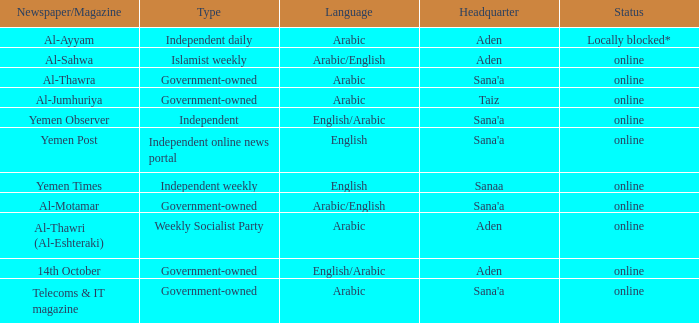What is the main office for the al-ayyam newspaper/magazine? Aden. 